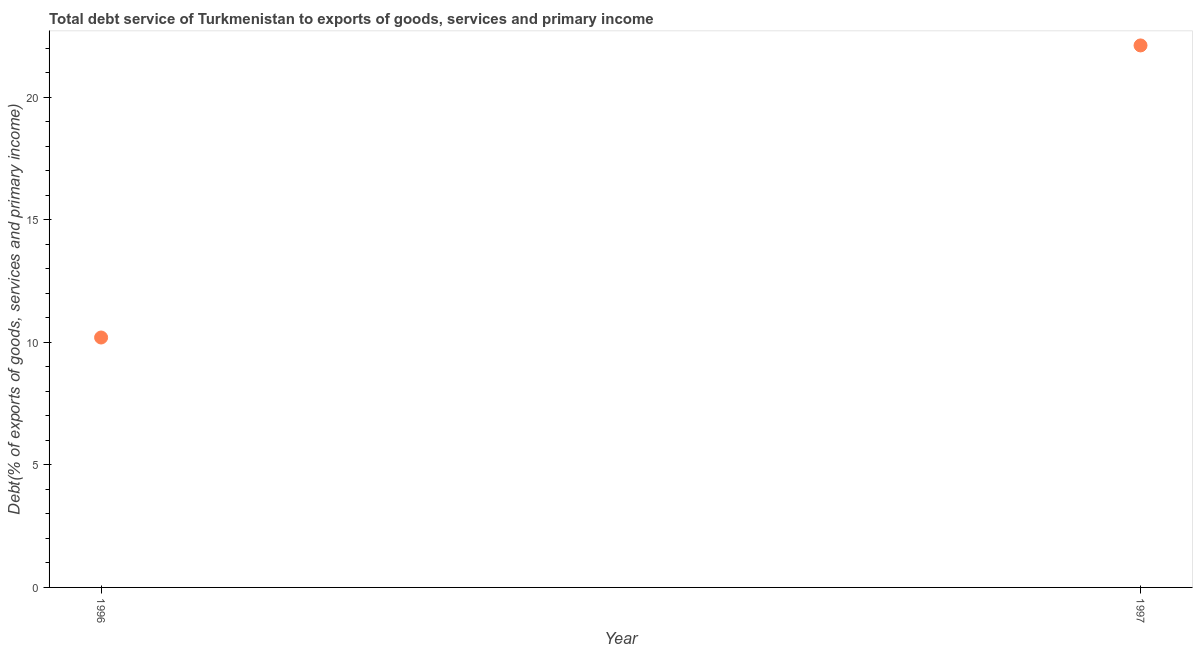What is the total debt service in 1996?
Your answer should be compact. 10.2. Across all years, what is the maximum total debt service?
Your response must be concise. 22.11. Across all years, what is the minimum total debt service?
Provide a succinct answer. 10.2. What is the sum of the total debt service?
Offer a terse response. 32.31. What is the difference between the total debt service in 1996 and 1997?
Provide a short and direct response. -11.92. What is the average total debt service per year?
Your answer should be very brief. 16.15. What is the median total debt service?
Your answer should be very brief. 16.15. Do a majority of the years between 1997 and 1996 (inclusive) have total debt service greater than 11 %?
Offer a terse response. No. What is the ratio of the total debt service in 1996 to that in 1997?
Your answer should be very brief. 0.46. Is the total debt service in 1996 less than that in 1997?
Provide a short and direct response. Yes. Does the total debt service monotonically increase over the years?
Make the answer very short. Yes. What is the title of the graph?
Your response must be concise. Total debt service of Turkmenistan to exports of goods, services and primary income. What is the label or title of the X-axis?
Make the answer very short. Year. What is the label or title of the Y-axis?
Your answer should be very brief. Debt(% of exports of goods, services and primary income). What is the Debt(% of exports of goods, services and primary income) in 1996?
Provide a short and direct response. 10.2. What is the Debt(% of exports of goods, services and primary income) in 1997?
Provide a short and direct response. 22.11. What is the difference between the Debt(% of exports of goods, services and primary income) in 1996 and 1997?
Offer a terse response. -11.92. What is the ratio of the Debt(% of exports of goods, services and primary income) in 1996 to that in 1997?
Ensure brevity in your answer.  0.46. 